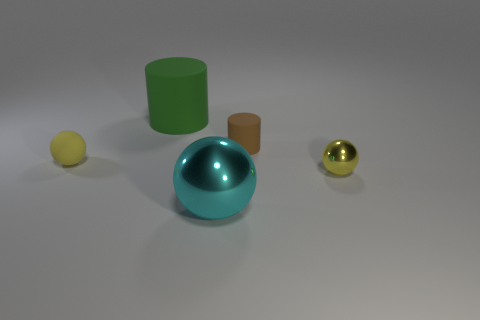Are there fewer rubber balls that are left of the small metallic sphere than matte things?
Your answer should be very brief. Yes. Do the cyan sphere and the green cylinder have the same material?
Your answer should be very brief. No. There is another metallic thing that is the same shape as the yellow shiny object; what is its size?
Provide a succinct answer. Large. What number of things are yellow balls that are in front of the small yellow rubber object or tiny rubber things that are to the left of the large cyan shiny thing?
Offer a terse response. 2. Are there fewer small brown cylinders than large gray metallic spheres?
Provide a succinct answer. No. There is a yellow metal thing; is its size the same as the rubber cylinder on the left side of the small brown rubber cylinder?
Your answer should be very brief. No. How many rubber objects are either large gray spheres or large green cylinders?
Provide a succinct answer. 1. Is the number of big cyan metallic balls greater than the number of purple shiny cylinders?
Offer a very short reply. Yes. There is another sphere that is the same color as the small metal ball; what is its size?
Your answer should be very brief. Small. There is a thing that is in front of the yellow object right of the yellow matte sphere; what shape is it?
Your answer should be compact. Sphere. 